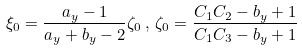Convert formula to latex. <formula><loc_0><loc_0><loc_500><loc_500>\xi _ { 0 } = \frac { a _ { y } - 1 } { a _ { y } + b _ { y } - 2 } \zeta _ { 0 } \, , \, \zeta _ { 0 } = \frac { C _ { 1 } C _ { 2 } - b _ { y } + 1 } { C _ { 1 } C _ { 3 } - b _ { y } + 1 }</formula> 